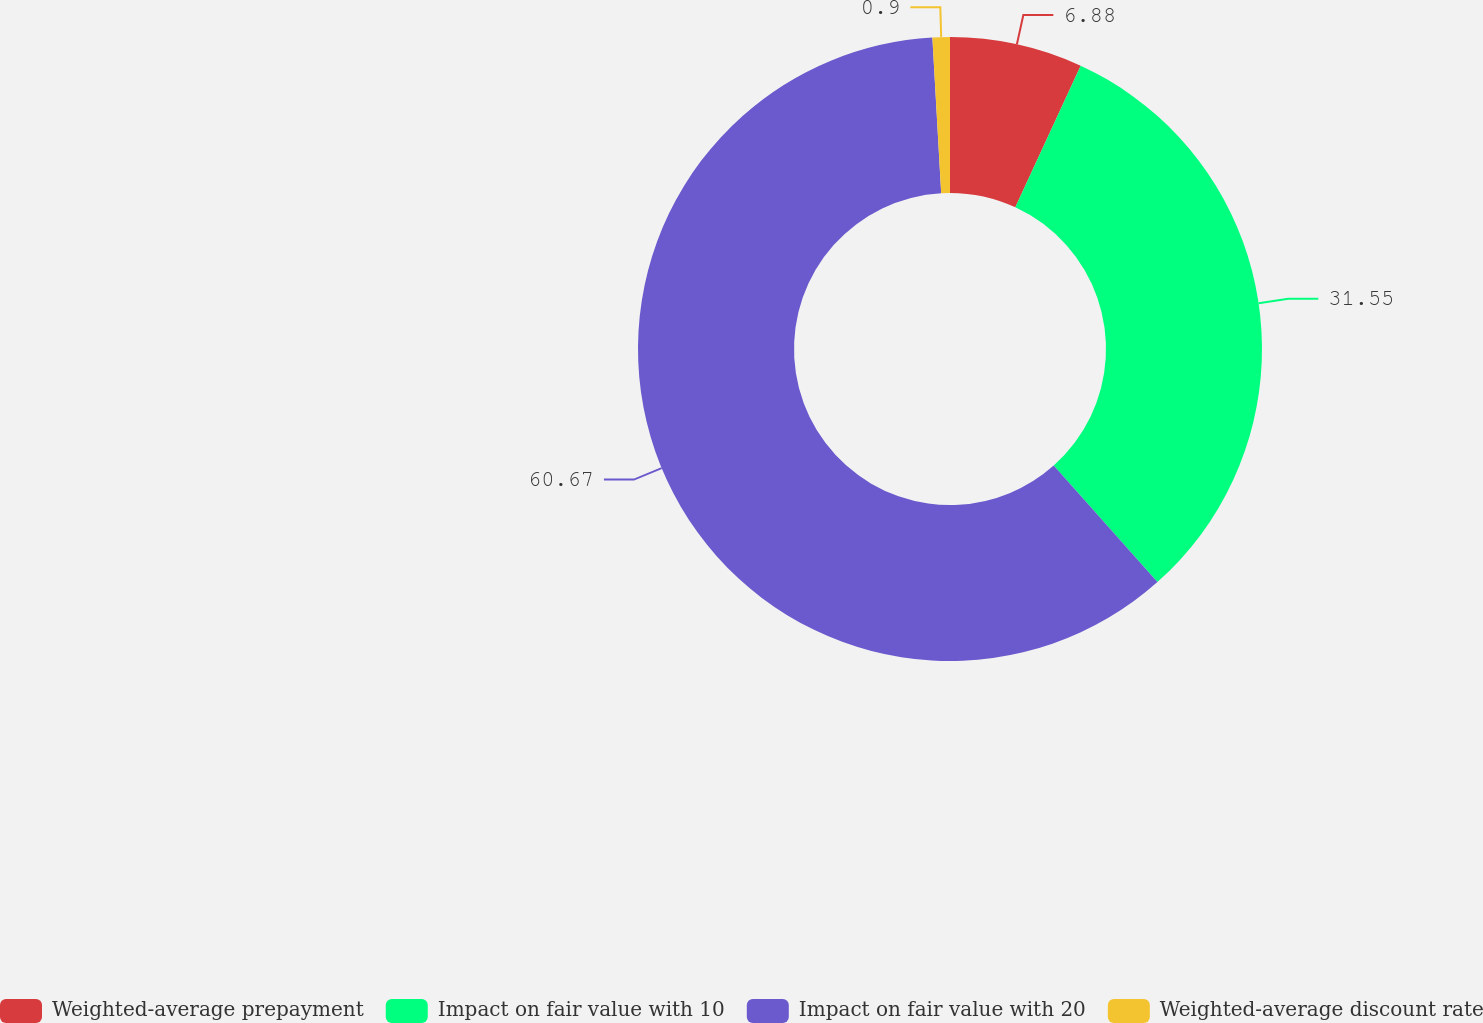Convert chart. <chart><loc_0><loc_0><loc_500><loc_500><pie_chart><fcel>Weighted-average prepayment<fcel>Impact on fair value with 10<fcel>Impact on fair value with 20<fcel>Weighted-average discount rate<nl><fcel>6.88%<fcel>31.55%<fcel>60.68%<fcel>0.9%<nl></chart> 